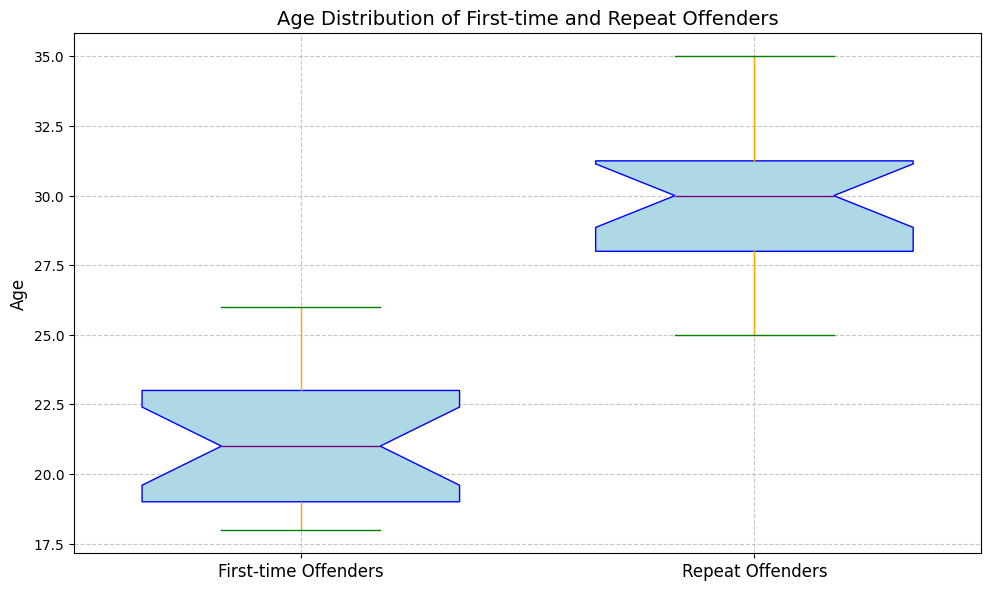What's the median age of first-time offenders? The box plot has a line inside the box that represents the median. Find the position of this line within the box for first-time offenders.
Answer: 21 What's the interquartile range (IQR) for repeat offenders? IQR is the difference between the 75th percentile (upper quartile) and 25th percentile (lower quartile). On the box plot, this is the distance between the top and bottom edges of the box for repeat offenders.
Answer: 4 What is the range of ages for first-time offenders? The range is the difference between the maximum and minimum values. Check the top of the upper whisker and the bottom of the lower whisker for first-time offenders.
Answer: 8 Which group has a higher median age? Compare the position of the median lines within the boxes for both first-time and repeat offenders. The median for repeat offenders is higher.
Answer: Repeat offenders What is the maximum recorded age for repeat offenders? Look at the top of the upper whisker for repeat offenders to find the maximum age.
Answer: 35 Are there any outliers for first-time offenders? Outliers are typically marked as individual points outside the whiskers. Check if there are any red markers for first-time offenders.
Answer: No By how many years does the median age of repeat offenders exceed that of first-time offenders? Subtract the median age of first-time offenders from the median age of repeat offenders.
Answer: 9 Which group shows more age variability, as indicated by the whisker length? Longer whiskers indicate more variability. Compare the length of the whiskers for both groups. The whiskers for first-time offenders are longer.
Answer: First-time offenders Which group has more compact age distribution based on the interquartile range (IQR)? A smaller IQR indicates a more compact distribution. Compare the height of the boxes (IQR) for both groups.
Answer: Repeat offenders 